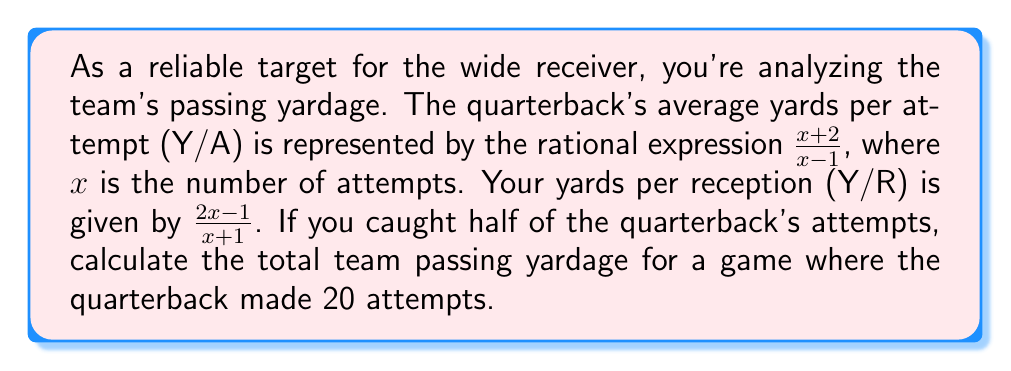Provide a solution to this math problem. Let's approach this step-by-step:

1) First, we need to find the quarterback's Y/A when $x = 20$:
   $$Y/A = \frac{x+2}{x-1} = \frac{20+2}{20-1} = \frac{22}{19}$$

2) Next, we calculate your Y/R when $x = 20$:
   $$Y/R = \frac{2x-1}{x+1} = \frac{2(20)-1}{20+1} = \frac{39}{21}$$

3) The total passing yardage is the sum of:
   a) Yards from passes you caught
   b) Yards from passes caught by others

4) You caught half of the attempts, so you caught 10 passes (20/2 = 10).
   Your total yards: $10 \cdot \frac{39}{21}$

5) The other half of the passes (10) were caught by others.
   Their total yards: $10 \cdot \frac{22}{19}$

6) Now we add these together:
   $$\text{Total Yardage} = 10 \cdot \frac{39}{21} + 10 \cdot \frac{22}{19}$$

7) Simplifying:
   $$\text{Total Yardage} = \frac{390}{21} + \frac{220}{19}$$

8) To add these fractions, we need a common denominator (21 * 19 = 399):
   $$\text{Total Yardage} = \frac{390 \cdot 19}{399} + \frac{220 \cdot 21}{399} = \frac{7410 + 4620}{399} = \frac{12030}{399} = 30.15$$

Therefore, the total team passing yardage is 30.15 yards (rounded to two decimal places).
Answer: 30.15 yards 